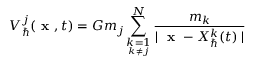Convert formula to latex. <formula><loc_0><loc_0><loc_500><loc_500>V _ { } ^ { j } ( x , t ) = G m _ { j } \sum _ { \underset { k \neq j } { k = 1 } } ^ { N } \frac { m _ { k } } { | x - X _ { } ^ { k } ( t ) | }</formula> 